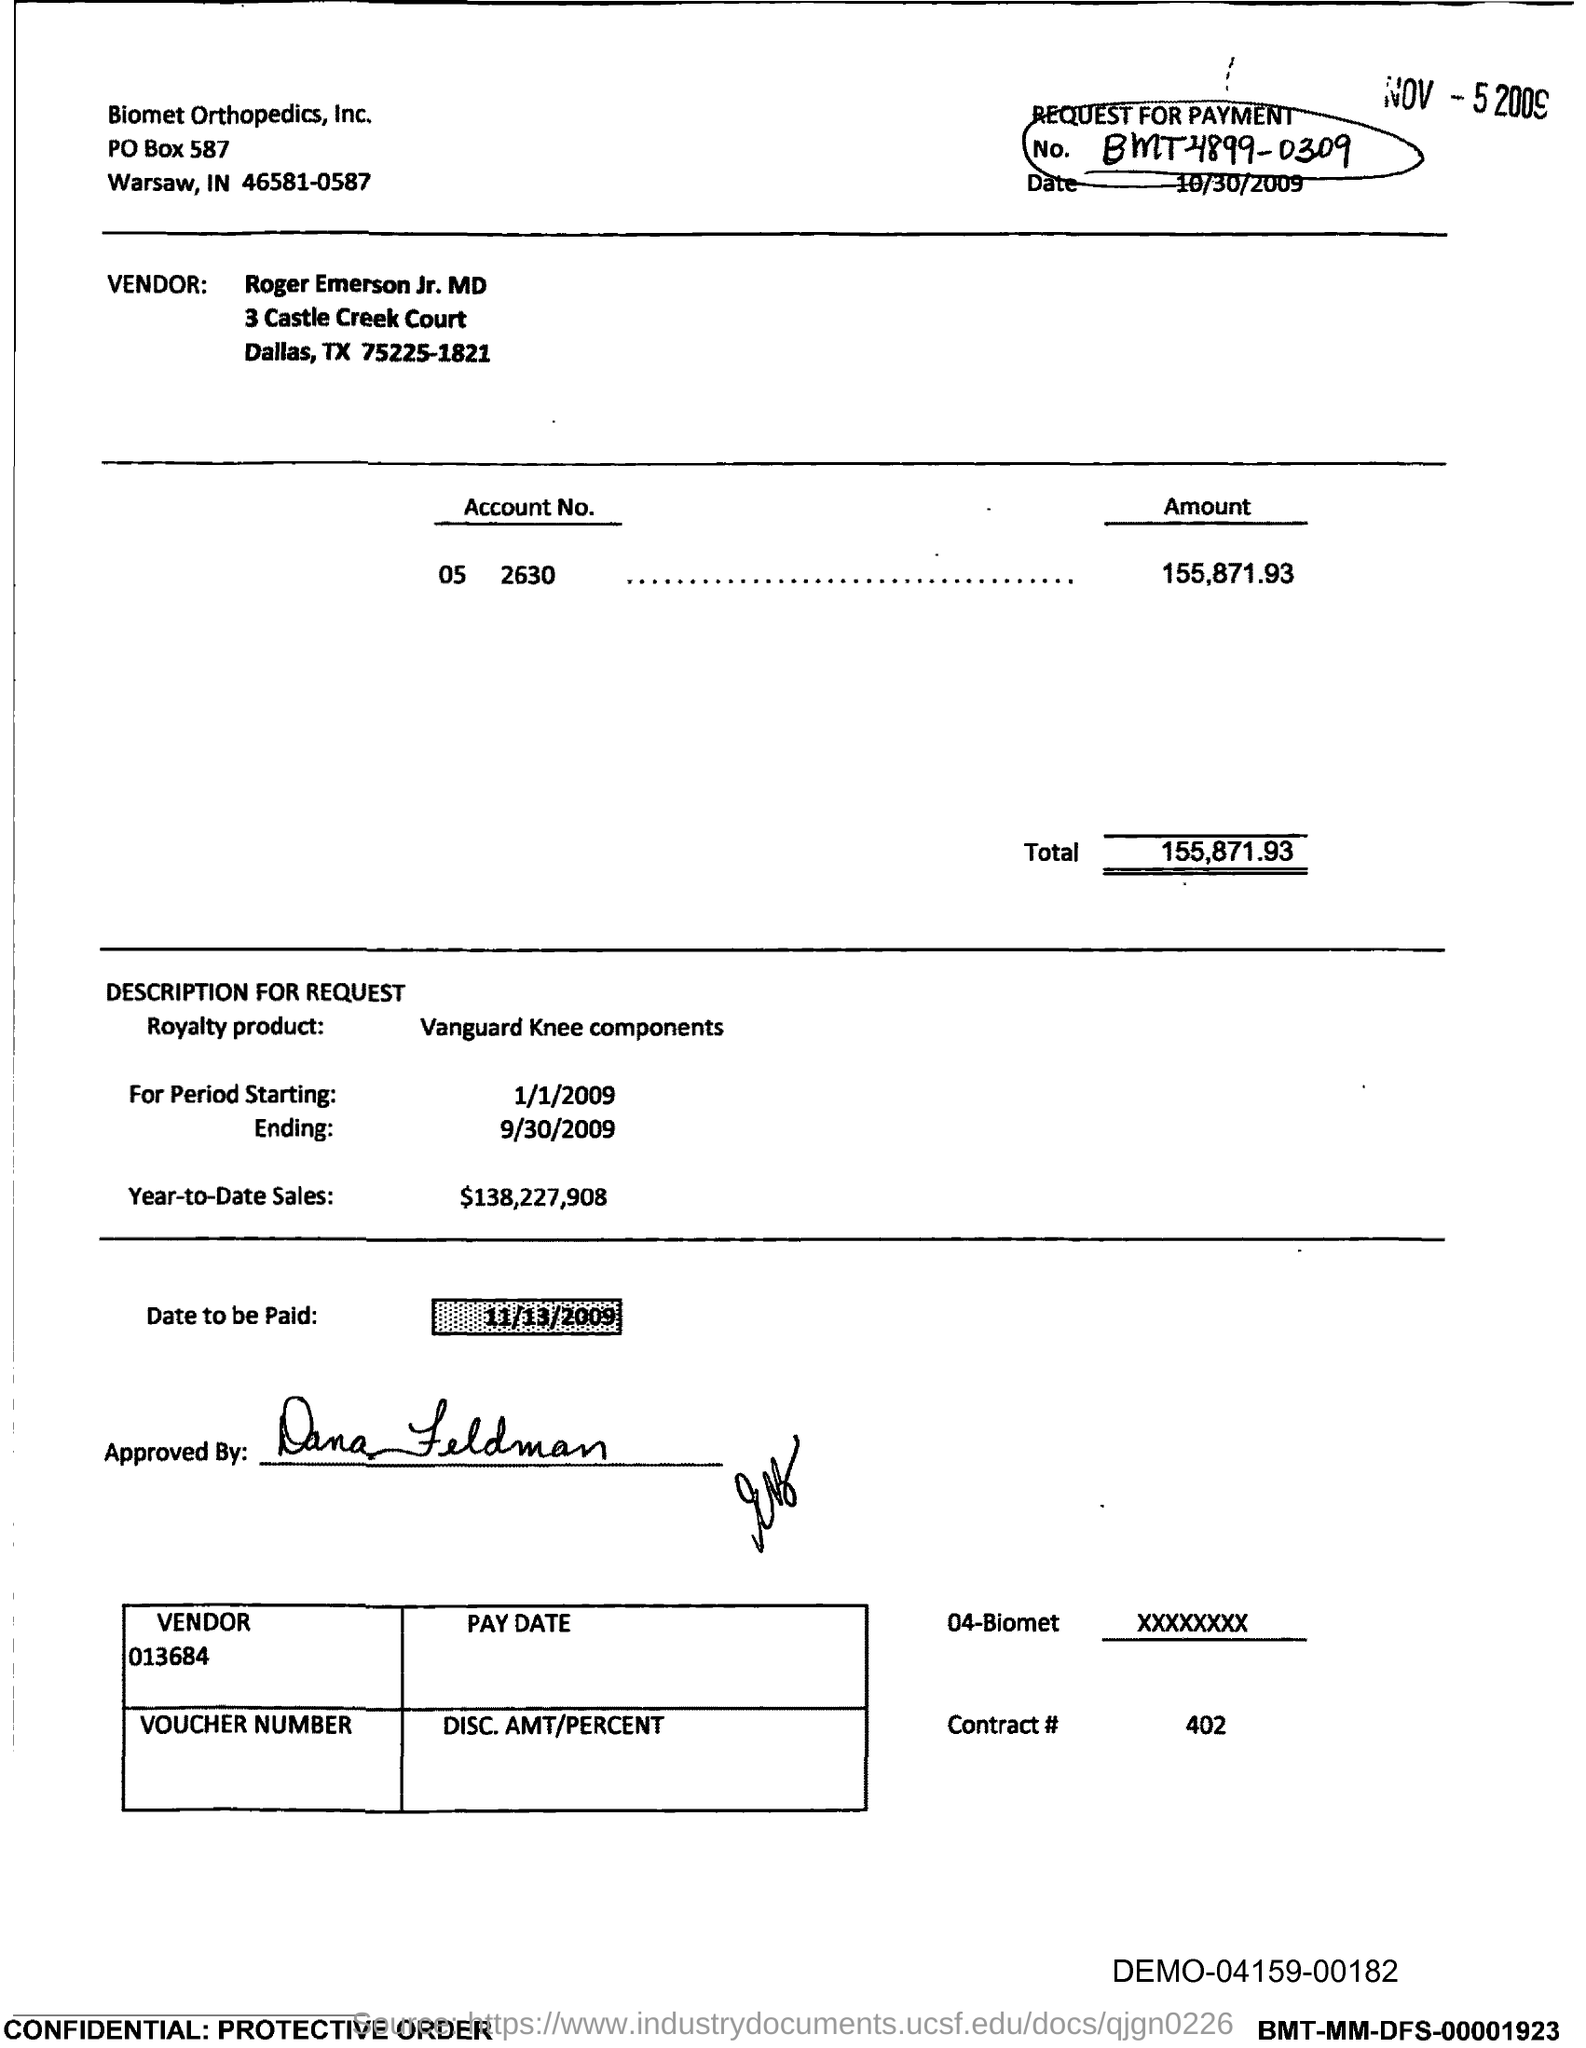Give some essential details in this illustration. The number circled at the top right corner is BMT4899-0309. The period ending date is September 30, 2009. The total amount is 155,871.93. The street address of the vendor is 3 Castle Creek Court. On what date is the payment to be made? 